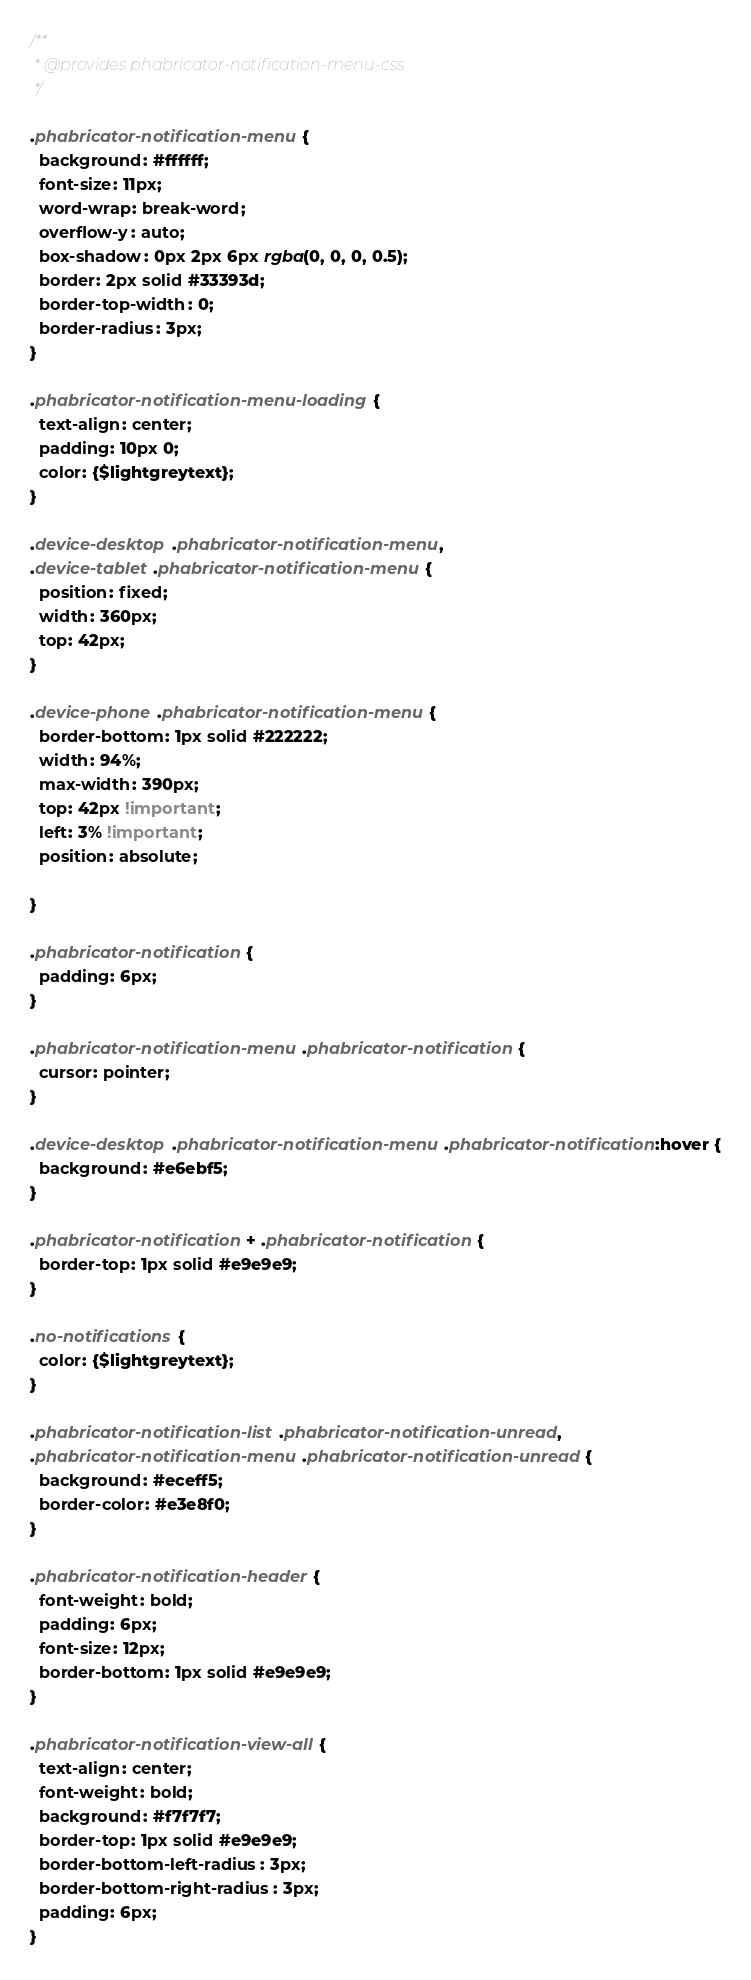Convert code to text. <code><loc_0><loc_0><loc_500><loc_500><_CSS_>/**
 * @provides phabricator-notification-menu-css
 */

.phabricator-notification-menu {
  background: #ffffff;
  font-size: 11px;
  word-wrap: break-word;
  overflow-y: auto;
  box-shadow: 0px 2px 6px rgba(0, 0, 0, 0.5);
  border: 2px solid #33393d;
  border-top-width: 0;
  border-radius: 3px;
}

.phabricator-notification-menu-loading {
  text-align: center;
  padding: 10px 0;
  color: {$lightgreytext};
}

.device-desktop .phabricator-notification-menu,
.device-tablet .phabricator-notification-menu {
  position: fixed;
  width: 360px;
  top: 42px;
}

.device-phone .phabricator-notification-menu {
  border-bottom: 1px solid #222222;
  width: 94%;
  max-width: 390px;
  top: 42px !important;
  left: 3% !important;
  position: absolute;

}

.phabricator-notification {
  padding: 6px;
}

.phabricator-notification-menu .phabricator-notification {
  cursor: pointer;
}

.device-desktop .phabricator-notification-menu .phabricator-notification:hover {
  background: #e6ebf5;
}

.phabricator-notification + .phabricator-notification {
  border-top: 1px solid #e9e9e9;
}

.no-notifications {
  color: {$lightgreytext};
}

.phabricator-notification-list .phabricator-notification-unread,
.phabricator-notification-menu .phabricator-notification-unread {
  background: #eceff5;
  border-color: #e3e8f0;
}

.phabricator-notification-header {
  font-weight: bold;
  padding: 6px;
  font-size: 12px;
  border-bottom: 1px solid #e9e9e9;
}

.phabricator-notification-view-all {
  text-align: center;
  font-weight: bold;
  background: #f7f7f7;
  border-top: 1px solid #e9e9e9;
  border-bottom-left-radius: 3px;
  border-bottom-right-radius: 3px;
  padding: 6px;
}
</code> 